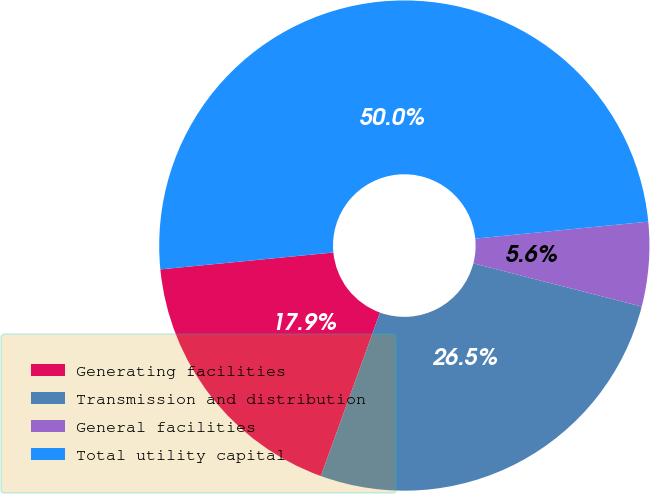Convert chart to OTSL. <chart><loc_0><loc_0><loc_500><loc_500><pie_chart><fcel>Generating facilities<fcel>Transmission and distribution<fcel>General facilities<fcel>Total utility capital<nl><fcel>17.92%<fcel>26.53%<fcel>5.56%<fcel>50.0%<nl></chart> 